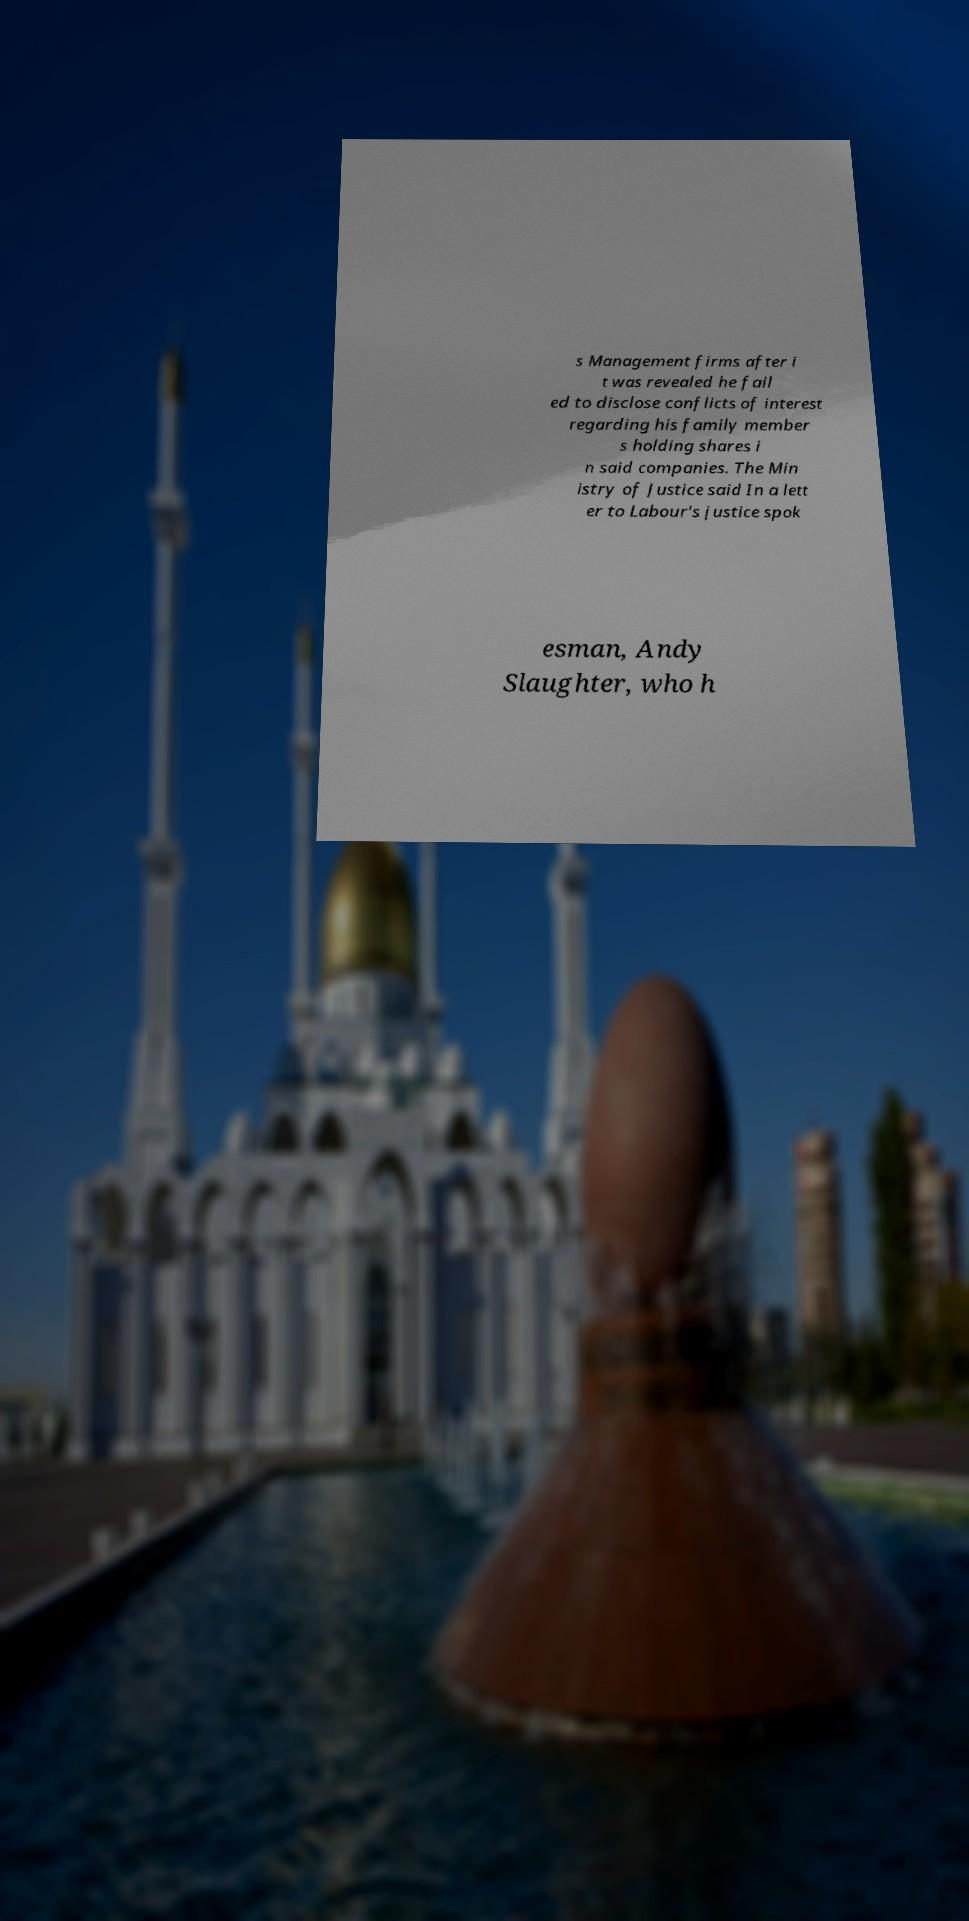What messages or text are displayed in this image? I need them in a readable, typed format. s Management firms after i t was revealed he fail ed to disclose conflicts of interest regarding his family member s holding shares i n said companies. The Min istry of Justice said In a lett er to Labour's justice spok esman, Andy Slaughter, who h 